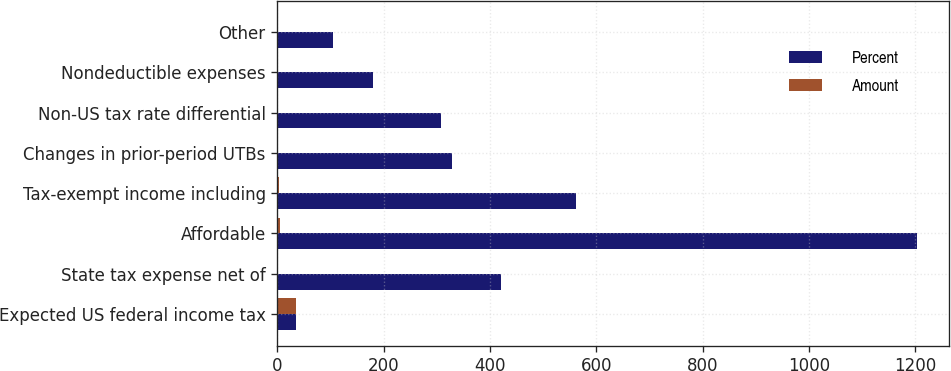Convert chart. <chart><loc_0><loc_0><loc_500><loc_500><stacked_bar_chart><ecel><fcel>Expected US federal income tax<fcel>State tax expense net of<fcel>Affordable<fcel>Tax-exempt income including<fcel>Changes in prior-period UTBs<fcel>Non-US tax rate differential<fcel>Nondeductible expenses<fcel>Other<nl><fcel>Percent<fcel>35<fcel>420<fcel>1203<fcel>562<fcel>328<fcel>307<fcel>180<fcel>105<nl><fcel>Amount<fcel>35<fcel>1.7<fcel>4.8<fcel>2.3<fcel>1.3<fcel>1.2<fcel>0.7<fcel>0.4<nl></chart> 